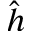Convert formula to latex. <formula><loc_0><loc_0><loc_500><loc_500>\hat { h }</formula> 